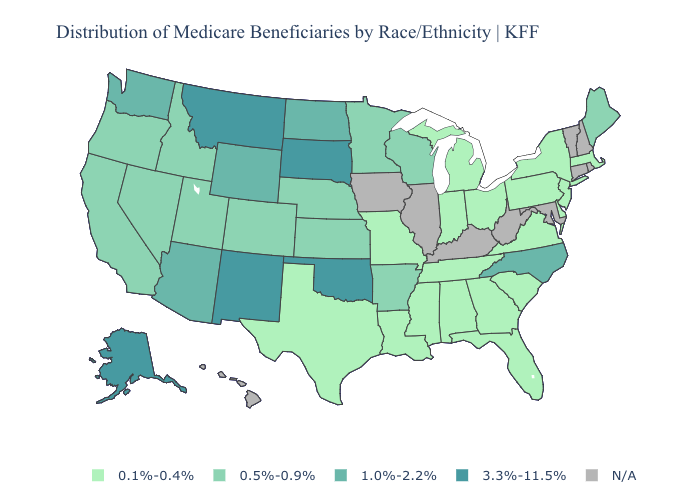Does the first symbol in the legend represent the smallest category?
Be succinct. Yes. What is the value of Nevada?
Answer briefly. 0.5%-0.9%. Does Kansas have the highest value in the USA?
Give a very brief answer. No. What is the lowest value in the West?
Concise answer only. 0.5%-0.9%. Is the legend a continuous bar?
Short answer required. No. Does Nebraska have the lowest value in the MidWest?
Keep it brief. No. Name the states that have a value in the range 3.3%-11.5%?
Write a very short answer. Alaska, Montana, New Mexico, Oklahoma, South Dakota. Does Indiana have the highest value in the USA?
Quick response, please. No. Name the states that have a value in the range 3.3%-11.5%?
Be succinct. Alaska, Montana, New Mexico, Oklahoma, South Dakota. Name the states that have a value in the range N/A?
Keep it brief. Connecticut, Hawaii, Illinois, Iowa, Kentucky, Maryland, New Hampshire, Rhode Island, Vermont, West Virginia. Name the states that have a value in the range 3.3%-11.5%?
Be succinct. Alaska, Montana, New Mexico, Oklahoma, South Dakota. Does the first symbol in the legend represent the smallest category?
Write a very short answer. Yes. 